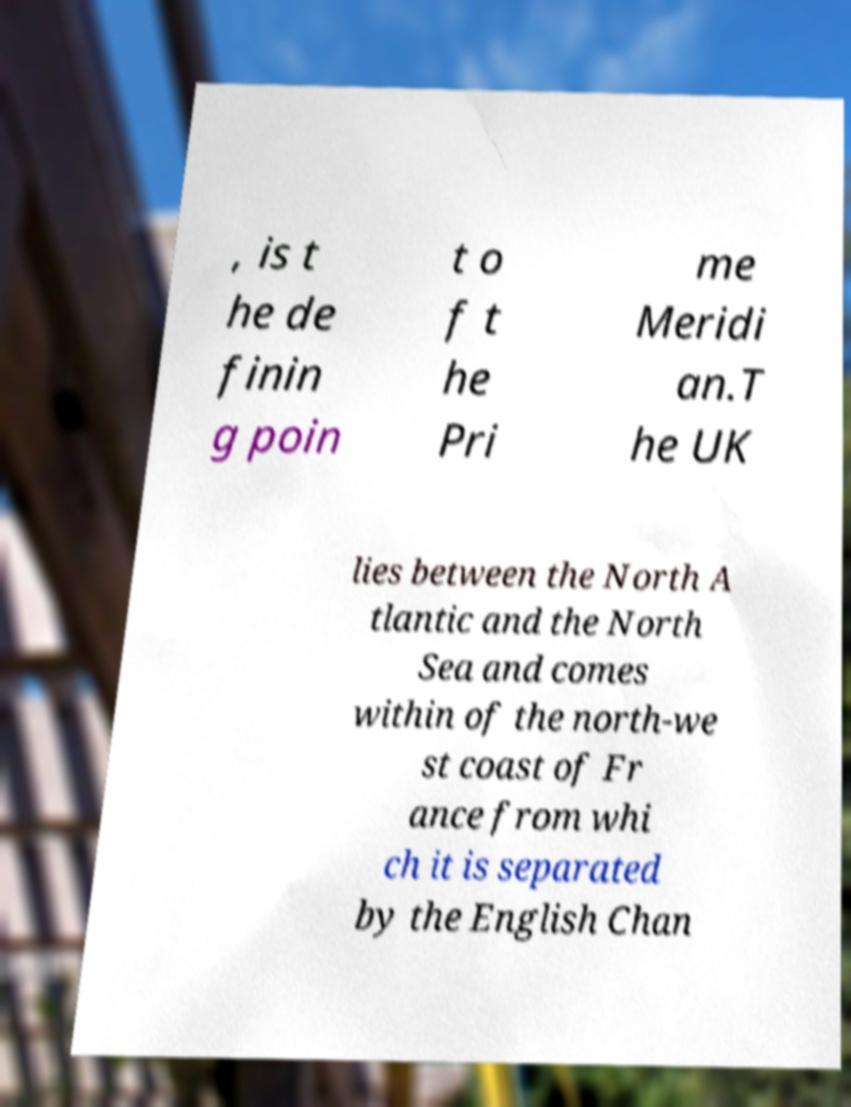There's text embedded in this image that I need extracted. Can you transcribe it verbatim? , is t he de finin g poin t o f t he Pri me Meridi an.T he UK lies between the North A tlantic and the North Sea and comes within of the north-we st coast of Fr ance from whi ch it is separated by the English Chan 